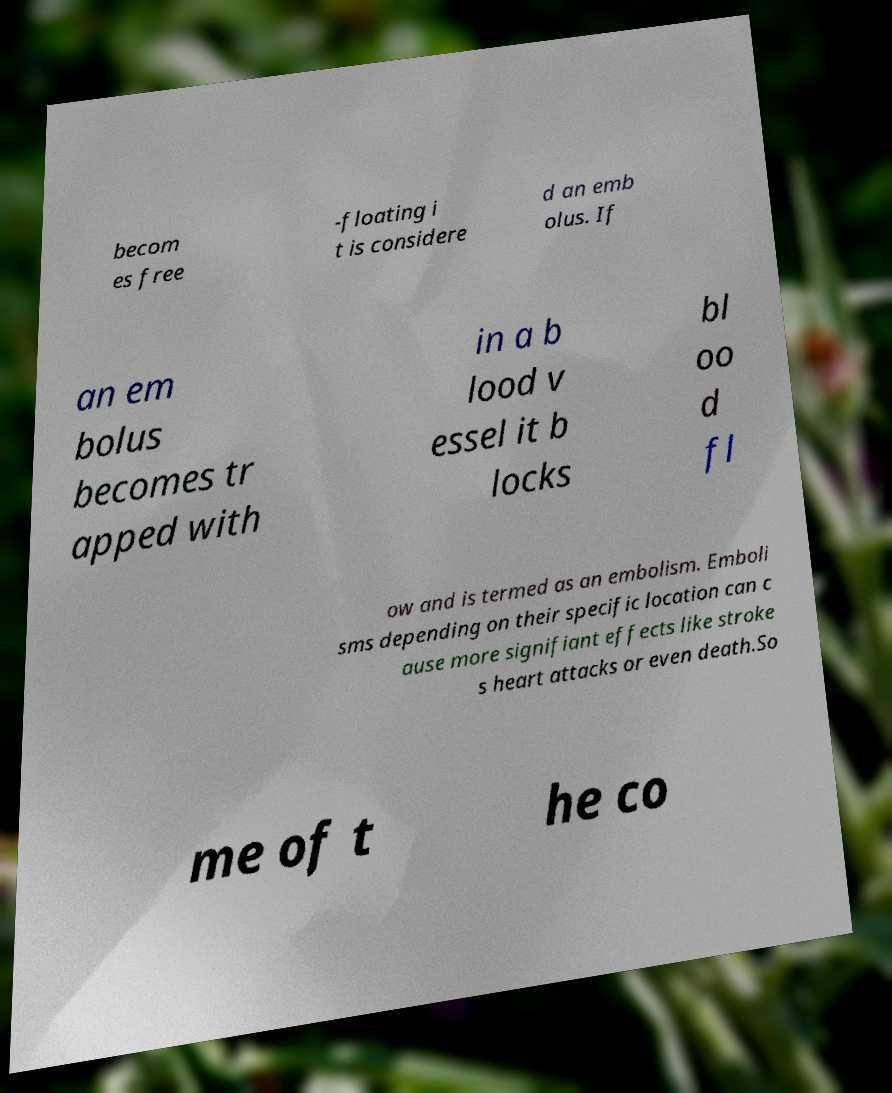For documentation purposes, I need the text within this image transcribed. Could you provide that? becom es free -floating i t is considere d an emb olus. If an em bolus becomes tr apped with in a b lood v essel it b locks bl oo d fl ow and is termed as an embolism. Emboli sms depending on their specific location can c ause more signifiant effects like stroke s heart attacks or even death.So me of t he co 